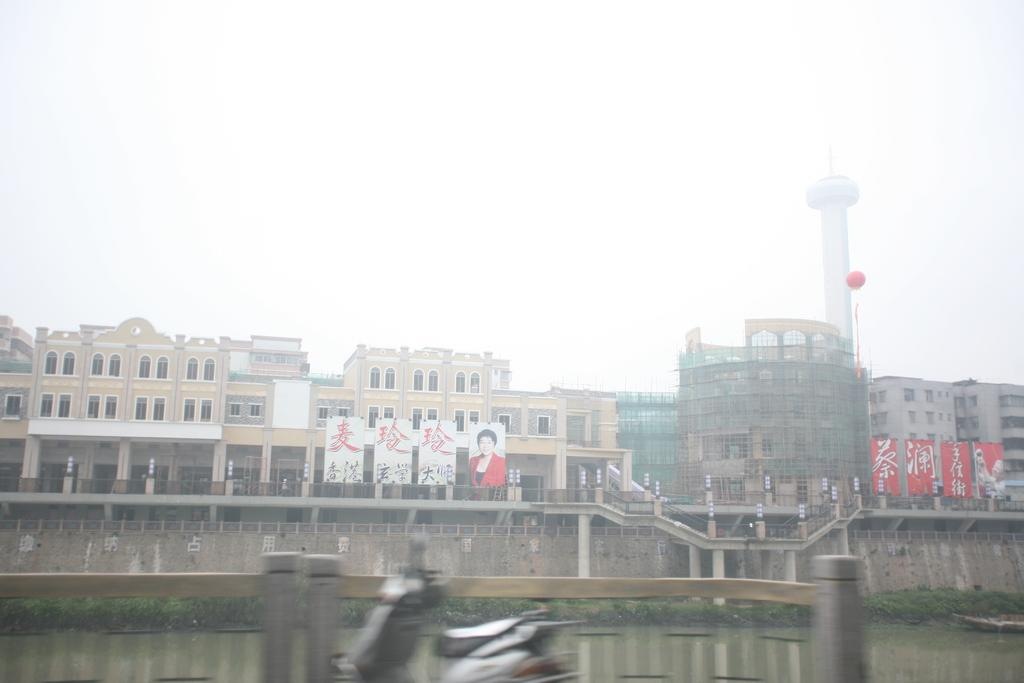What type of structures can be seen in the image? There are buildings in the image. What decorative elements are present in the image? There are banners in the image. What part of the natural environment is visible in the image? The sky and water are visible in the image. What type of vegetation can be seen in the image? There are plants in the image. Despite the blurred bottom, what mode of transportation can be seen in the image? A vehicle is visible in the image. What type of barrier is present in the image? A fence is visible in the image. What type of lettuce is being used to form a meat sculpture in the image? There is no lettuce or meat sculpture present in the image. 